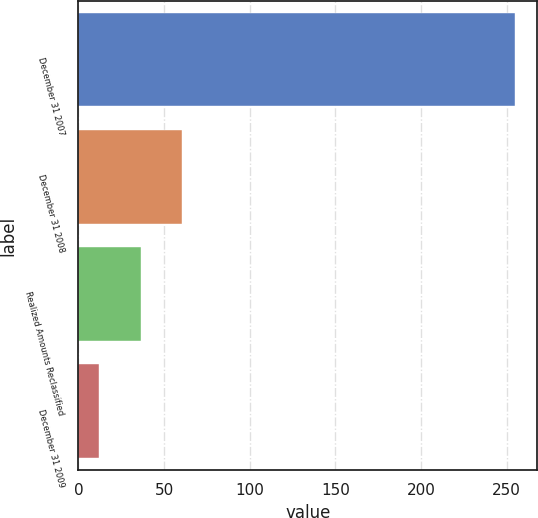Convert chart. <chart><loc_0><loc_0><loc_500><loc_500><bar_chart><fcel>December 31 2007<fcel>December 31 2008<fcel>Realized Amounts Reclassified<fcel>December 31 2009<nl><fcel>255<fcel>60.6<fcel>36.3<fcel>12<nl></chart> 